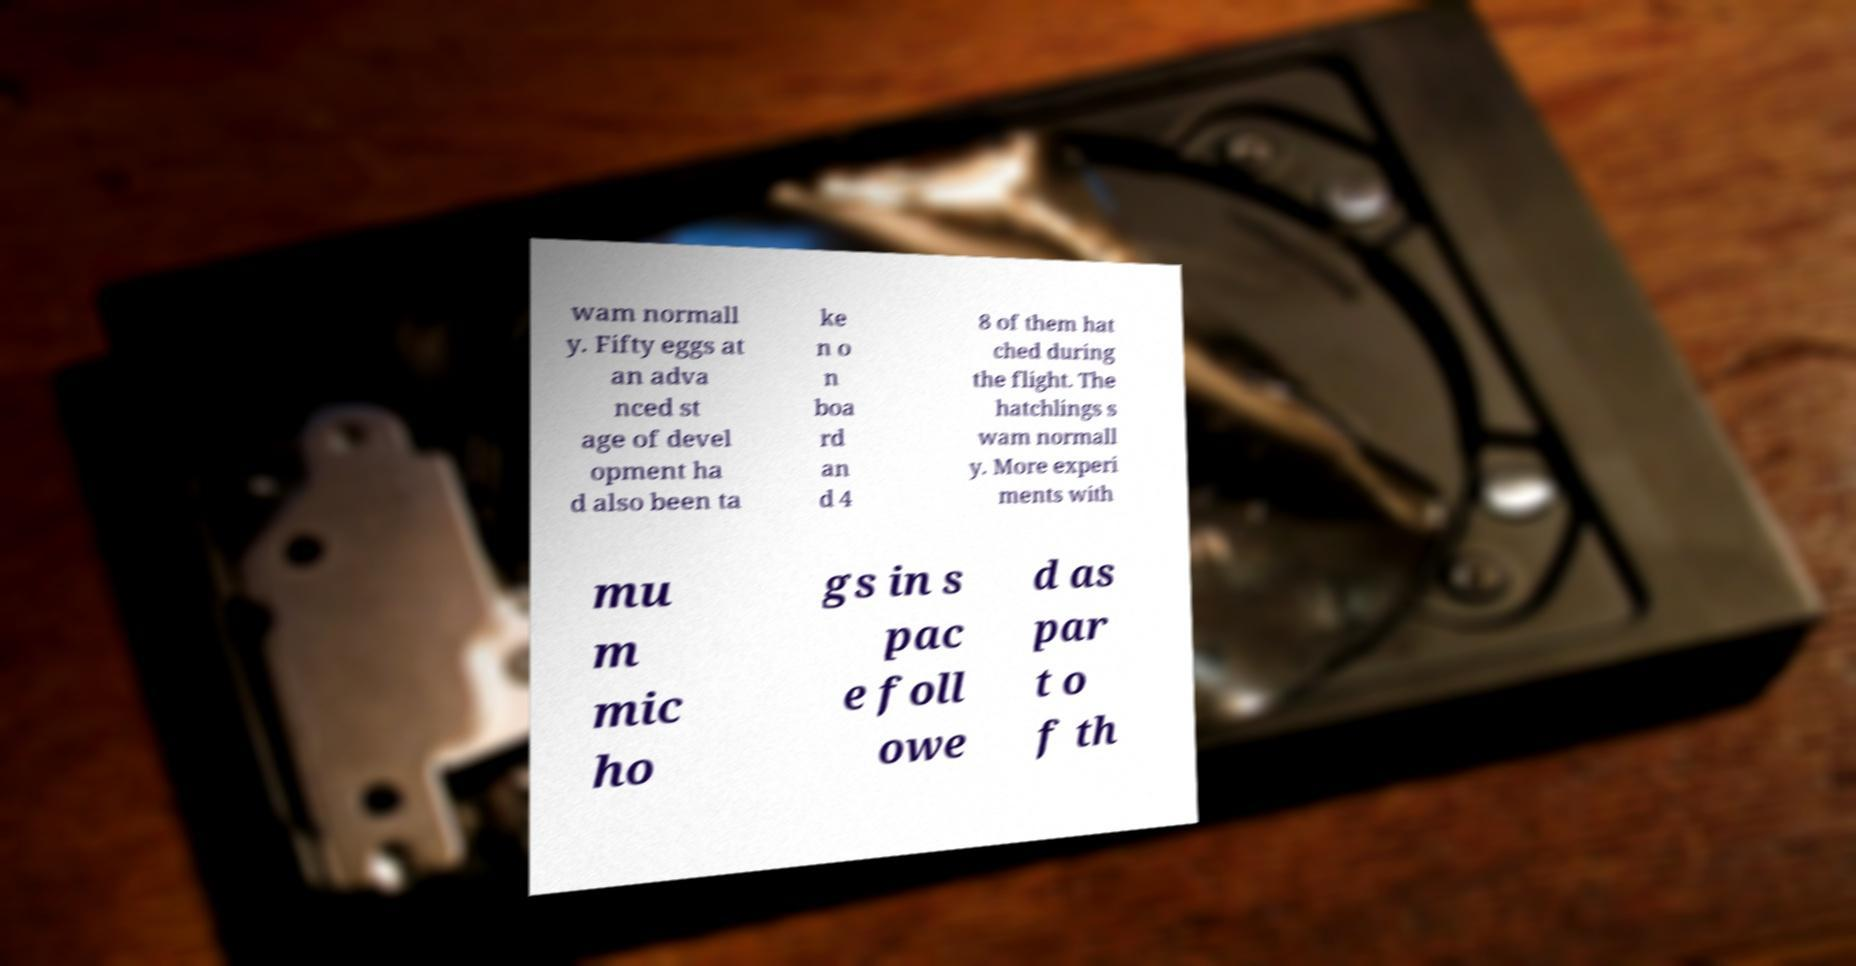Could you assist in decoding the text presented in this image and type it out clearly? wam normall y. Fifty eggs at an adva nced st age of devel opment ha d also been ta ke n o n boa rd an d 4 8 of them hat ched during the flight. The hatchlings s wam normall y. More experi ments with mu m mic ho gs in s pac e foll owe d as par t o f th 